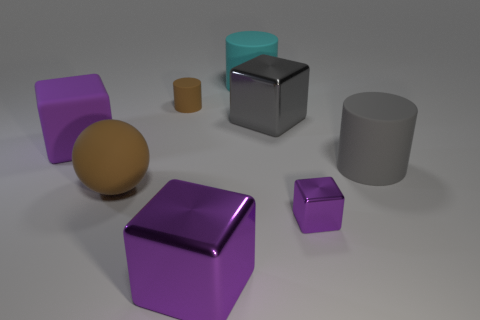There is a large cube that is in front of the matte block; what is its material?
Your response must be concise. Metal. Are the tiny cube that is right of the large gray block and the large gray block made of the same material?
Ensure brevity in your answer.  Yes. Is there a big brown rubber ball?
Make the answer very short. Yes. There is a large block that is made of the same material as the cyan thing; what is its color?
Give a very brief answer. Purple. There is a large matte thing that is to the right of the purple shiny block on the right side of the big block that is in front of the big brown object; what is its color?
Provide a short and direct response. Gray. Does the purple rubber block have the same size as the purple metal cube that is to the right of the big purple metallic block?
Give a very brief answer. No. What number of things are purple metallic blocks that are on the right side of the purple matte block or large rubber things behind the tiny cylinder?
Provide a succinct answer. 3. What shape is the brown matte object that is the same size as the cyan rubber cylinder?
Your response must be concise. Sphere. What shape is the big gray matte object behind the big shiny cube that is in front of the big purple block that is behind the matte ball?
Offer a terse response. Cylinder. Are there an equal number of small purple blocks right of the large purple matte block and big yellow rubber objects?
Give a very brief answer. No. 